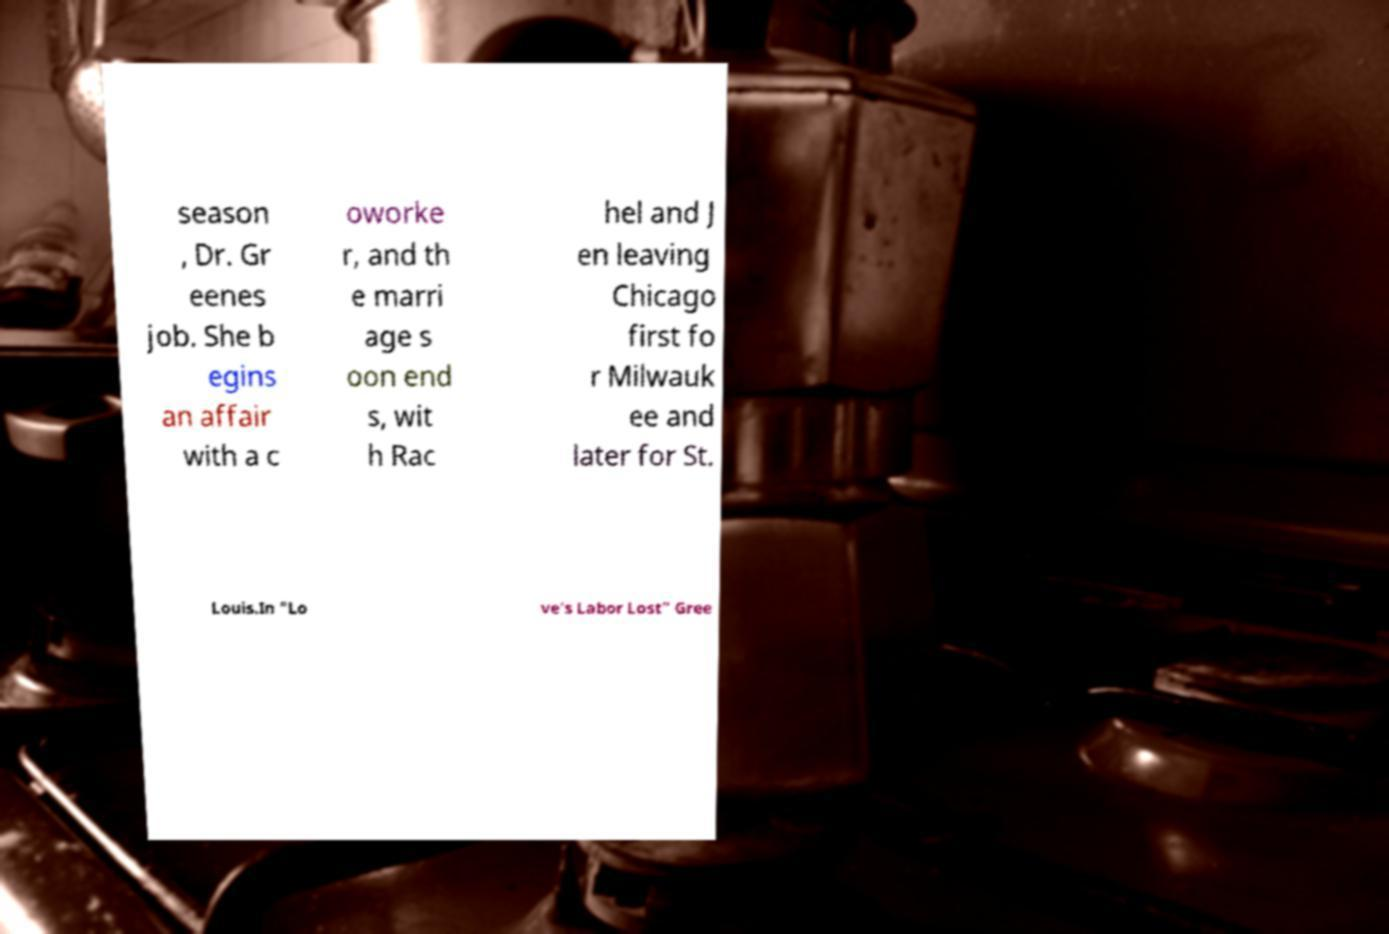Please identify and transcribe the text found in this image. season , Dr. Gr eenes job. She b egins an affair with a c oworke r, and th e marri age s oon end s, wit h Rac hel and J en leaving Chicago first fo r Milwauk ee and later for St. Louis.In "Lo ve's Labor Lost" Gree 